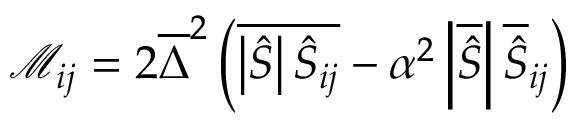<formula> <loc_0><loc_0><loc_500><loc_500>{ \mathcal { M } } _ { i j } = 2 { \overline { \Delta } } ^ { 2 } \left ( { \overline { { \left | { \hat { S } } \right | { \hat { S } } _ { i j } } } } - \alpha ^ { 2 } \left | { \overline { { \hat { S } } } } \right | { \overline { { \hat { S } } } } _ { i j } \right )</formula> 